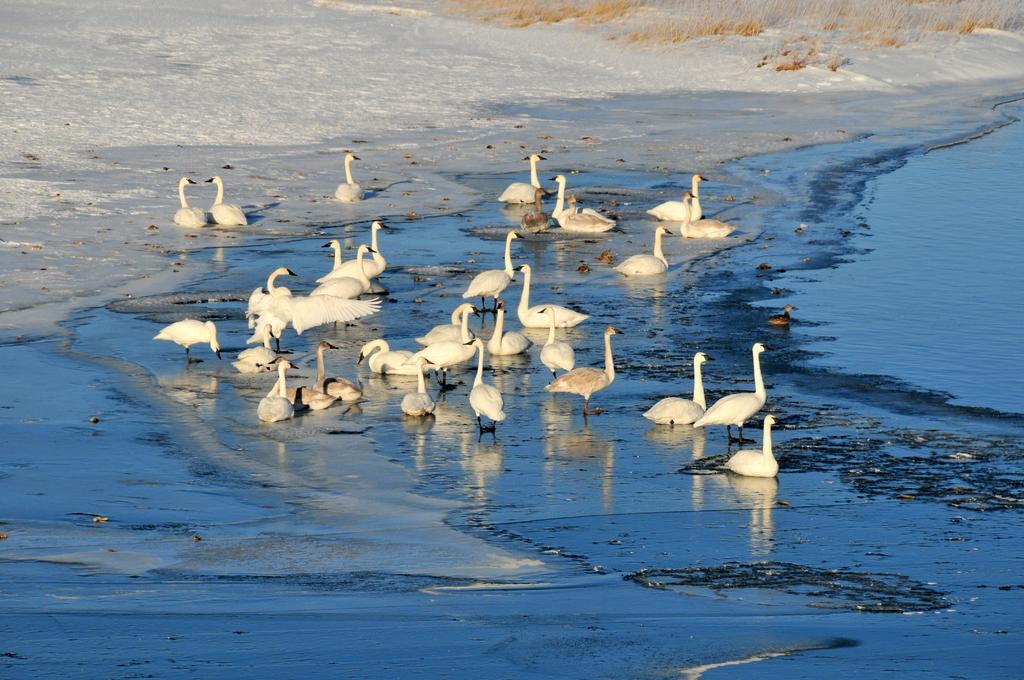Could you give a brief overview of what you see in this image? In this picture we can see swans here, on the right side there is water, we can see snow in the background. 